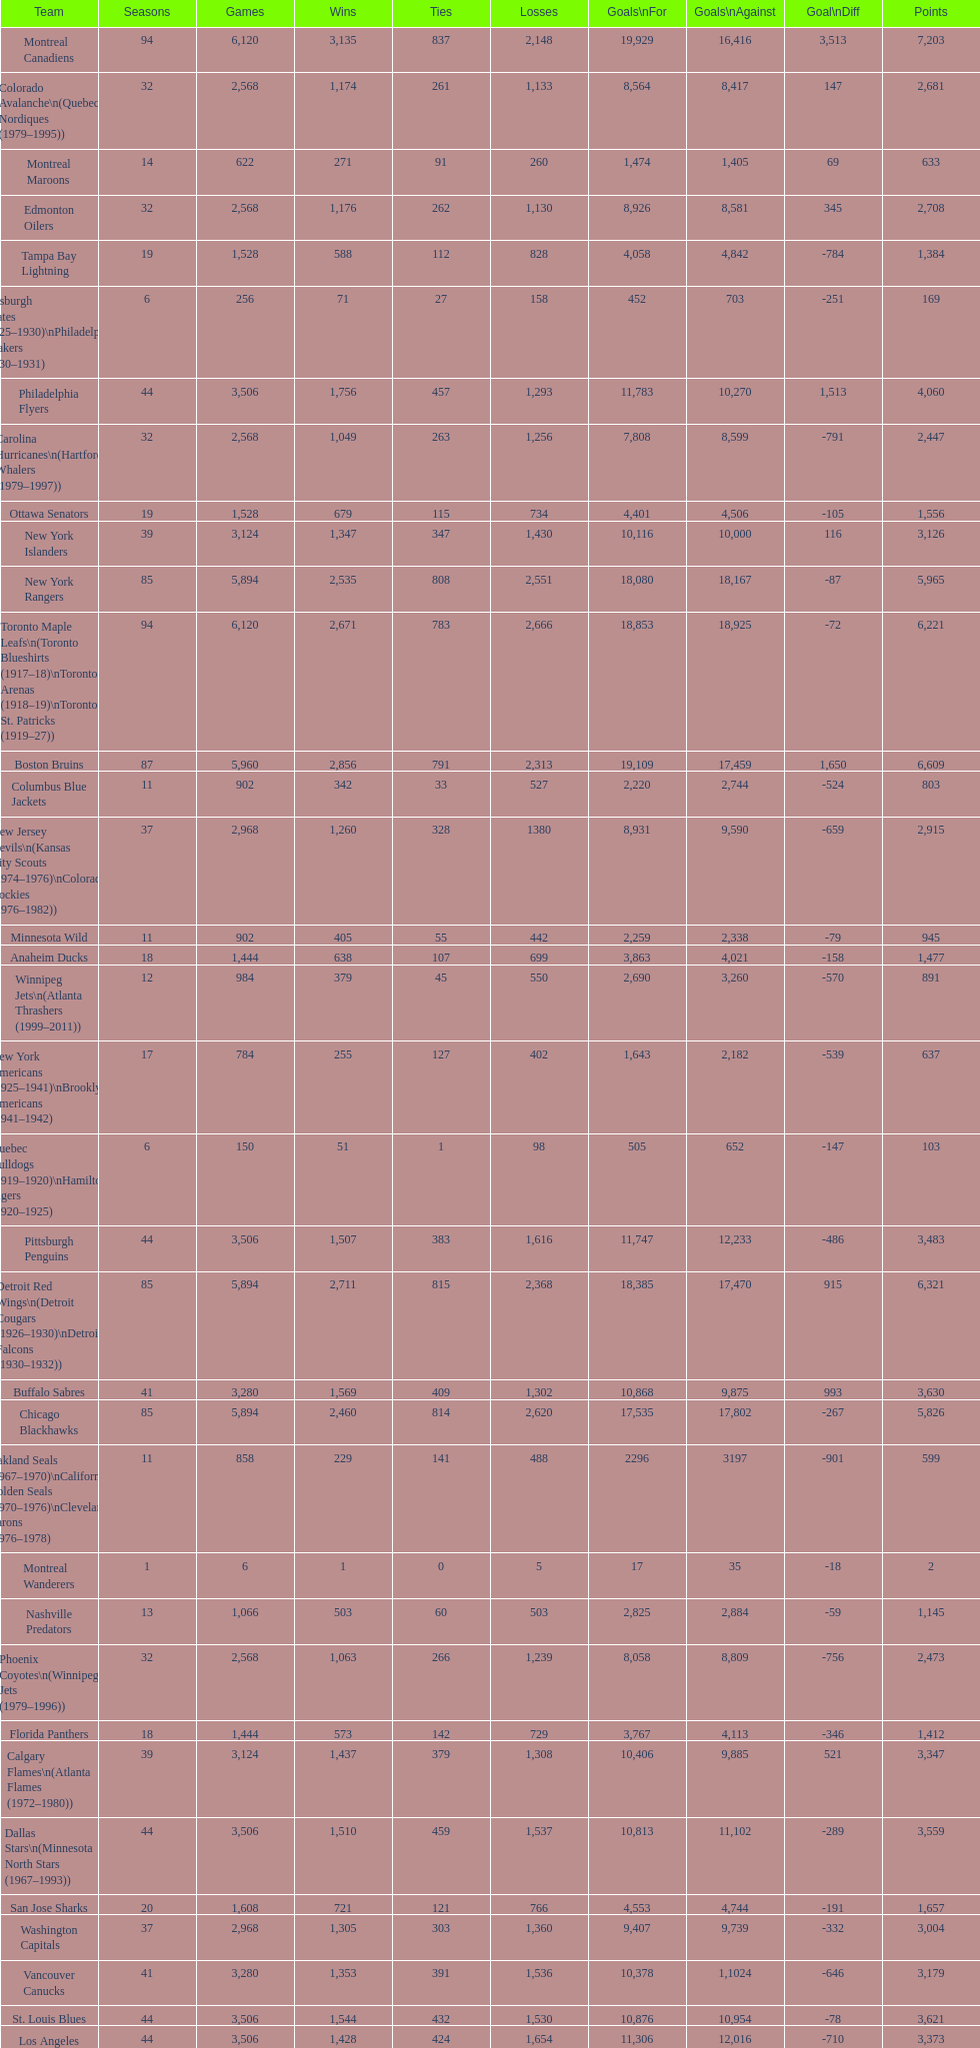How many total points has the lost angeles kings scored? 3,373. Could you help me parse every detail presented in this table? {'header': ['Team', 'Seasons', 'Games', 'Wins', 'Ties', 'Losses', 'Goals\\nFor', 'Goals\\nAgainst', 'Goal\\nDiff', 'Points'], 'rows': [['Montreal Canadiens', '94', '6,120', '3,135', '837', '2,148', '19,929', '16,416', '3,513', '7,203'], ['Colorado Avalanche\\n(Quebec Nordiques (1979–1995))', '32', '2,568', '1,174', '261', '1,133', '8,564', '8,417', '147', '2,681'], ['Montreal Maroons', '14', '622', '271', '91', '260', '1,474', '1,405', '69', '633'], ['Edmonton Oilers', '32', '2,568', '1,176', '262', '1,130', '8,926', '8,581', '345', '2,708'], ['Tampa Bay Lightning', '19', '1,528', '588', '112', '828', '4,058', '4,842', '-784', '1,384'], ['Pittsburgh Pirates (1925–1930)\\nPhiladelphia Quakers (1930–1931)', '6', '256', '71', '27', '158', '452', '703', '-251', '169'], ['Philadelphia Flyers', '44', '3,506', '1,756', '457', '1,293', '11,783', '10,270', '1,513', '4,060'], ['Carolina Hurricanes\\n(Hartford Whalers (1979–1997))', '32', '2,568', '1,049', '263', '1,256', '7,808', '8,599', '-791', '2,447'], ['Ottawa Senators', '19', '1,528', '679', '115', '734', '4,401', '4,506', '-105', '1,556'], ['New York Islanders', '39', '3,124', '1,347', '347', '1,430', '10,116', '10,000', '116', '3,126'], ['New York Rangers', '85', '5,894', '2,535', '808', '2,551', '18,080', '18,167', '-87', '5,965'], ['Toronto Maple Leafs\\n(Toronto Blueshirts (1917–18)\\nToronto Arenas (1918–19)\\nToronto St. Patricks (1919–27))', '94', '6,120', '2,671', '783', '2,666', '18,853', '18,925', '-72', '6,221'], ['Boston Bruins', '87', '5,960', '2,856', '791', '2,313', '19,109', '17,459', '1,650', '6,609'], ['Columbus Blue Jackets', '11', '902', '342', '33', '527', '2,220', '2,744', '-524', '803'], ['New Jersey Devils\\n(Kansas City Scouts (1974–1976)\\nColorado Rockies (1976–1982))', '37', '2,968', '1,260', '328', '1380', '8,931', '9,590', '-659', '2,915'], ['Minnesota Wild', '11', '902', '405', '55', '442', '2,259', '2,338', '-79', '945'], ['Anaheim Ducks', '18', '1,444', '638', '107', '699', '3,863', '4,021', '-158', '1,477'], ['Winnipeg Jets\\n(Atlanta Thrashers (1999–2011))', '12', '984', '379', '45', '550', '2,690', '3,260', '-570', '891'], ['New York Americans (1925–1941)\\nBrooklyn Americans (1941–1942)', '17', '784', '255', '127', '402', '1,643', '2,182', '-539', '637'], ['Quebec Bulldogs (1919–1920)\\nHamilton Tigers (1920–1925)', '6', '150', '51', '1', '98', '505', '652', '-147', '103'], ['Pittsburgh Penguins', '44', '3,506', '1,507', '383', '1,616', '11,747', '12,233', '-486', '3,483'], ['Detroit Red Wings\\n(Detroit Cougars (1926–1930)\\nDetroit Falcons (1930–1932))', '85', '5,894', '2,711', '815', '2,368', '18,385', '17,470', '915', '6,321'], ['Buffalo Sabres', '41', '3,280', '1,569', '409', '1,302', '10,868', '9,875', '993', '3,630'], ['Chicago Blackhawks', '85', '5,894', '2,460', '814', '2,620', '17,535', '17,802', '-267', '5,826'], ['Oakland Seals (1967–1970)\\nCalifornia Golden Seals (1970–1976)\\nCleveland Barons (1976–1978)', '11', '858', '229', '141', '488', '2296', '3197', '-901', '599'], ['Montreal Wanderers', '1', '6', '1', '0', '5', '17', '35', '-18', '2'], ['Nashville Predators', '13', '1,066', '503', '60', '503', '2,825', '2,884', '-59', '1,145'], ['Phoenix Coyotes\\n(Winnipeg Jets (1979–1996))', '32', '2,568', '1,063', '266', '1,239', '8,058', '8,809', '-756', '2,473'], ['Florida Panthers', '18', '1,444', '573', '142', '729', '3,767', '4,113', '-346', '1,412'], ['Calgary Flames\\n(Atlanta Flames (1972–1980))', '39', '3,124', '1,437', '379', '1,308', '10,406', '9,885', '521', '3,347'], ['Dallas Stars\\n(Minnesota North Stars (1967–1993))', '44', '3,506', '1,510', '459', '1,537', '10,813', '11,102', '-289', '3,559'], ['San Jose Sharks', '20', '1,608', '721', '121', '766', '4,553', '4,744', '-191', '1,657'], ['Washington Capitals', '37', '2,968', '1,305', '303', '1,360', '9,407', '9,739', '-332', '3,004'], ['Vancouver Canucks', '41', '3,280', '1,353', '391', '1,536', '10,378', '1,1024', '-646', '3,179'], ['St. Louis Blues', '44', '3,506', '1,544', '432', '1,530', '10,876', '10,954', '-78', '3,621'], ['Los Angeles Kings', '44', '3,506', '1,428', '424', '1,654', '11,306', '12,016', '-710', '3,373'], ['Ottawa Senators (1917–1934)\\nSt. Louis Eagles (1934–1935)', '17', '590', '269', '69', '252', '1,544', '1,478', '66', '607']]} 